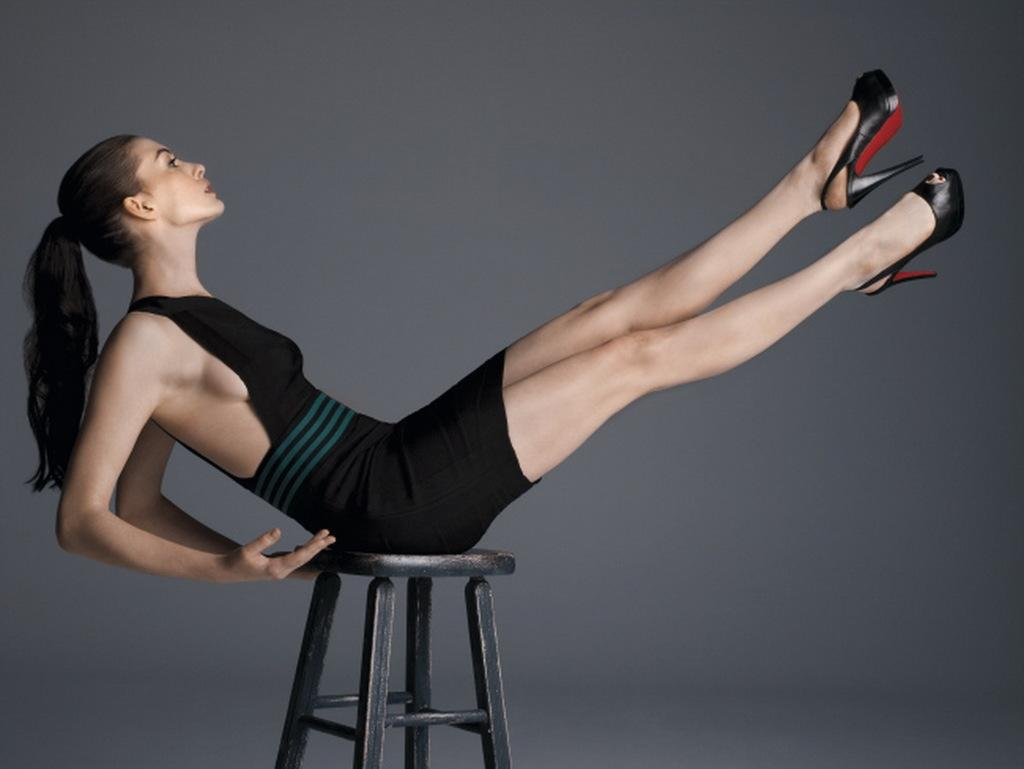Who is the main subject in the picture? There is a woman in the picture. What is the woman doing in the image? The woman is doing some exercise. What is the woman sitting on in the image? The woman is sitting on a stool. What color is the top the woman is wearing? The woman is wearing a black top. What type of footwear is the woman wearing? The woman is wearing heels. What type of soup is the woman eating in the image? There is no soup present in the image; the woman is doing exercises while sitting on a stool. 